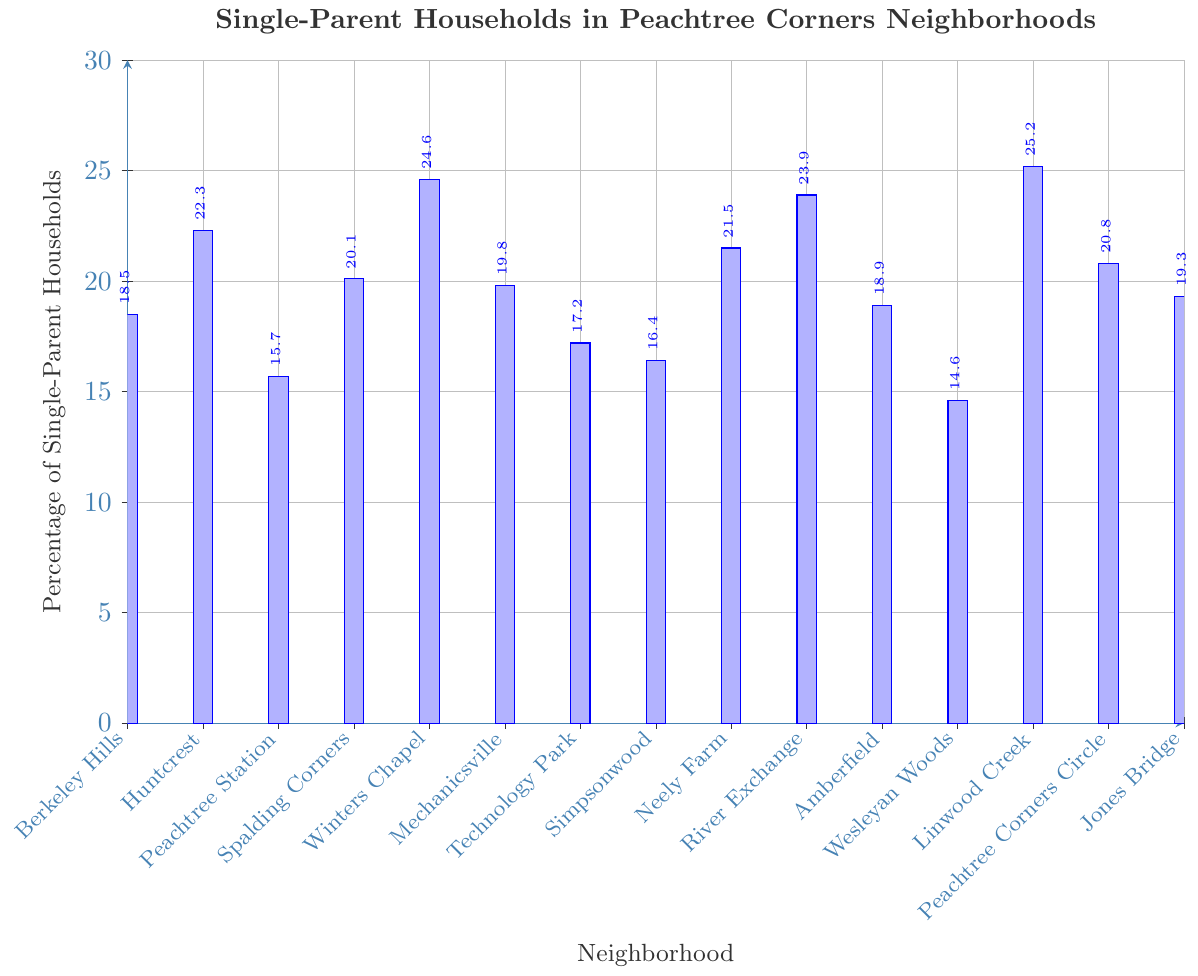What neighborhood has the highest percentage of single-parent households? We need to compare the percentages shown for each neighborhood. Linwood Creek has the highest percentage at 25.2%.
Answer: Linwood Creek What is the average percentage of single-parent households across all neighborhoods? Add all percentages and divide by the number of neighborhoods: (18.5 + 22.3 + 15.7 + 20.1 + 24.6 + 19.8 + 17.2 + 16.4 + 21.5 + 23.9 + 18.9 + 14.6 + 25.2 + 20.8 + 19.3) / 15 = 20.07.
Answer: 20.07 Which neighborhood has a lower percentage of single-parent households, Peachtree Station or Jones Bridge? Compare the percentages: Peachtree Station is 15.7% and Jones Bridge is 19.3%. Peachtree Station has a lower percentage.
Answer: Peachtree Station How many neighborhoods have a percentage of single-parent households greater than 20%? Count the neighborhoods with percentages over 20%: Huntcrest (22.3%), Spalding Corners (20.1%), Winters Chapel (24.6%), Neely Farm (21.5%), River Exchange (23.9%), Linwood Creek (25.2%), Peachtree Corners Circle (20.8%). There are 7 neighborhoods.
Answer: 7 What is the combined percentage of single-parent households for Berkeley Hills and Mechanicsville? Add the percentages: Berkeley Hills (18.5%) + Mechanicsville (19.8%) = 38.3%.
Answer: 38.3% Is the percentage of single-parent households higher in Technology Park or Amberfield? Compare the percentages: Technology Park (17.2%) and Amberfield (18.9%). Amberfield has a higher percentage.
Answer: Amberfield What is the difference in the percentage of single-parent households between Linwood Creek and Wesleyan Woods? Subtract Wesleyan Woods' percentage from Linwood Creek's: 25.2% - 14.6% = 10.6%.
Answer: 10.6% What neighborhood has the second lowest percentage of single-parent households? Find the second lowest by examining all percentages. Simpsonwood is second lowest at 16.4%.
Answer: Simpsonwood How does the percentage of single-parent households in Winters Chapel compare to Neely Farm? Compare the percentages: Winters Chapel (24.6%) and Neely Farm (21.5%). Winters Chapel has a higher percentage.
Answer: Winters Chapel What is the median percentage of single-parent households among all neighborhoods? Order the percentages and find the middle one: 14.6, 15.7, 16.4, 17.2, 18.5, 18.9, 19.3, 19.8, 20.1, 20.8, 21.5, 22.3, 23.9, 24.6, 25.2. The middle value (8th) is 19.8%.
Answer: 19.8% 